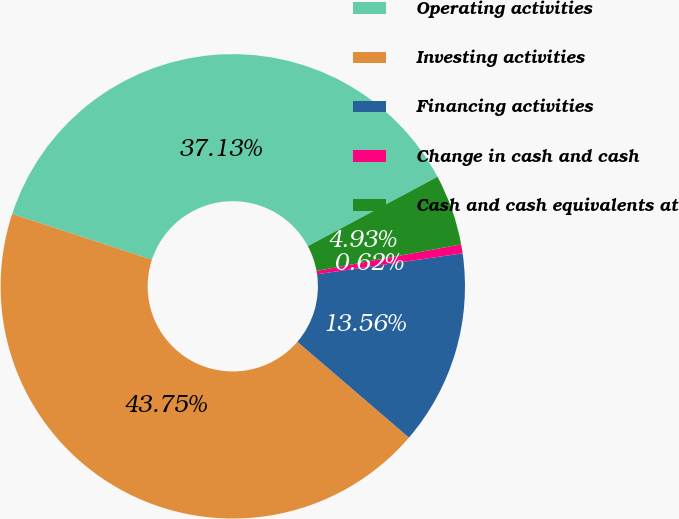<chart> <loc_0><loc_0><loc_500><loc_500><pie_chart><fcel>Operating activities<fcel>Investing activities<fcel>Financing activities<fcel>Change in cash and cash<fcel>Cash and cash equivalents at<nl><fcel>37.13%<fcel>43.75%<fcel>13.56%<fcel>0.62%<fcel>4.93%<nl></chart> 